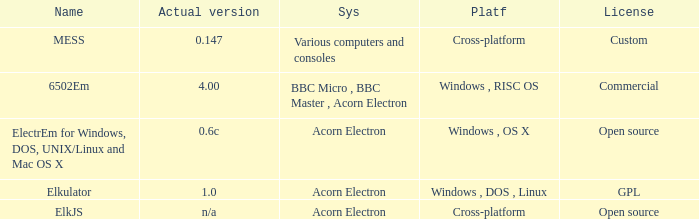Which system is named ELKJS? Acorn Electron. I'm looking to parse the entire table for insights. Could you assist me with that? {'header': ['Name', 'Actual version', 'Sys', 'Platf', 'License'], 'rows': [['MESS', '0.147', 'Various computers and consoles', 'Cross-platform', 'Custom'], ['6502Em', '4.00', 'BBC Micro , BBC Master , Acorn Electron', 'Windows , RISC OS', 'Commercial'], ['ElectrEm for Windows, DOS, UNIX/Linux and Mac OS X', '0.6c', 'Acorn Electron', 'Windows , OS X', 'Open source'], ['Elkulator', '1.0', 'Acorn Electron', 'Windows , DOS , Linux', 'GPL'], ['ElkJS', 'n/a', 'Acorn Electron', 'Cross-platform', 'Open source']]} 